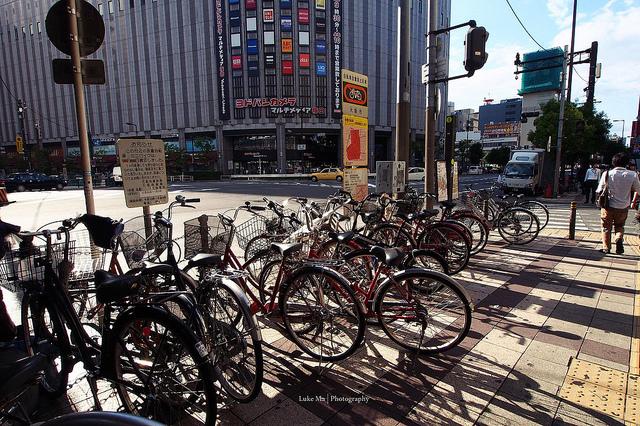Can you read all of the signs?
Answer briefly. No. Is there more than 5 bicycles?
Give a very brief answer. Yes. Are there bikes here?
Concise answer only. Yes. 